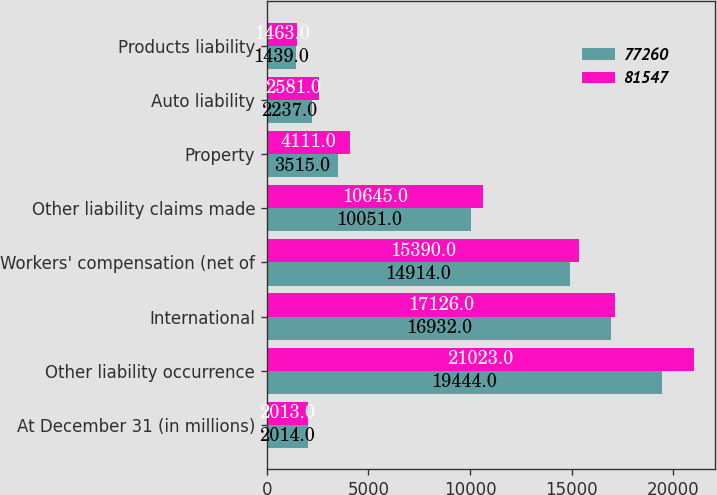Convert chart to OTSL. <chart><loc_0><loc_0><loc_500><loc_500><stacked_bar_chart><ecel><fcel>At December 31 (in millions)<fcel>Other liability occurrence<fcel>International<fcel>Workers' compensation (net of<fcel>Other liability claims made<fcel>Property<fcel>Auto liability<fcel>Products liability<nl><fcel>77260<fcel>2014<fcel>19444<fcel>16932<fcel>14914<fcel>10051<fcel>3515<fcel>2237<fcel>1439<nl><fcel>81547<fcel>2013<fcel>21023<fcel>17126<fcel>15390<fcel>10645<fcel>4111<fcel>2581<fcel>1463<nl></chart> 